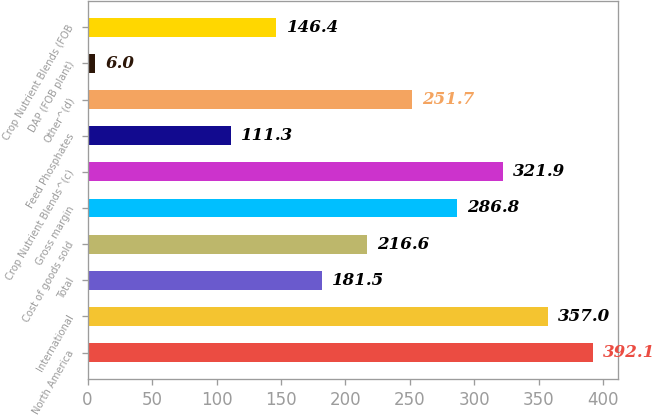<chart> <loc_0><loc_0><loc_500><loc_500><bar_chart><fcel>North America<fcel>International<fcel>Total<fcel>Cost of goods sold<fcel>Gross margin<fcel>Crop Nutrient Blends^(c)<fcel>Feed Phosphates<fcel>Other^(d)<fcel>DAP (FOB plant)<fcel>Crop Nutrient Blends (FOB<nl><fcel>392.1<fcel>357<fcel>181.5<fcel>216.6<fcel>286.8<fcel>321.9<fcel>111.3<fcel>251.7<fcel>6<fcel>146.4<nl></chart> 